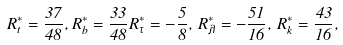Convert formula to latex. <formula><loc_0><loc_0><loc_500><loc_500>R _ { t } ^ { * } = { \frac { 3 7 } { 4 8 } } , R _ { b } ^ { * } = { \frac { 3 3 } { 4 8 } } R _ { \tau } ^ { * } = - { \frac { 5 } { 8 } } , \, R _ { \lambda } ^ { * } = - { \frac { 5 1 } { 1 6 } } , \, R _ { k } ^ { * } = { \frac { 4 3 } { 1 6 } } ,</formula> 